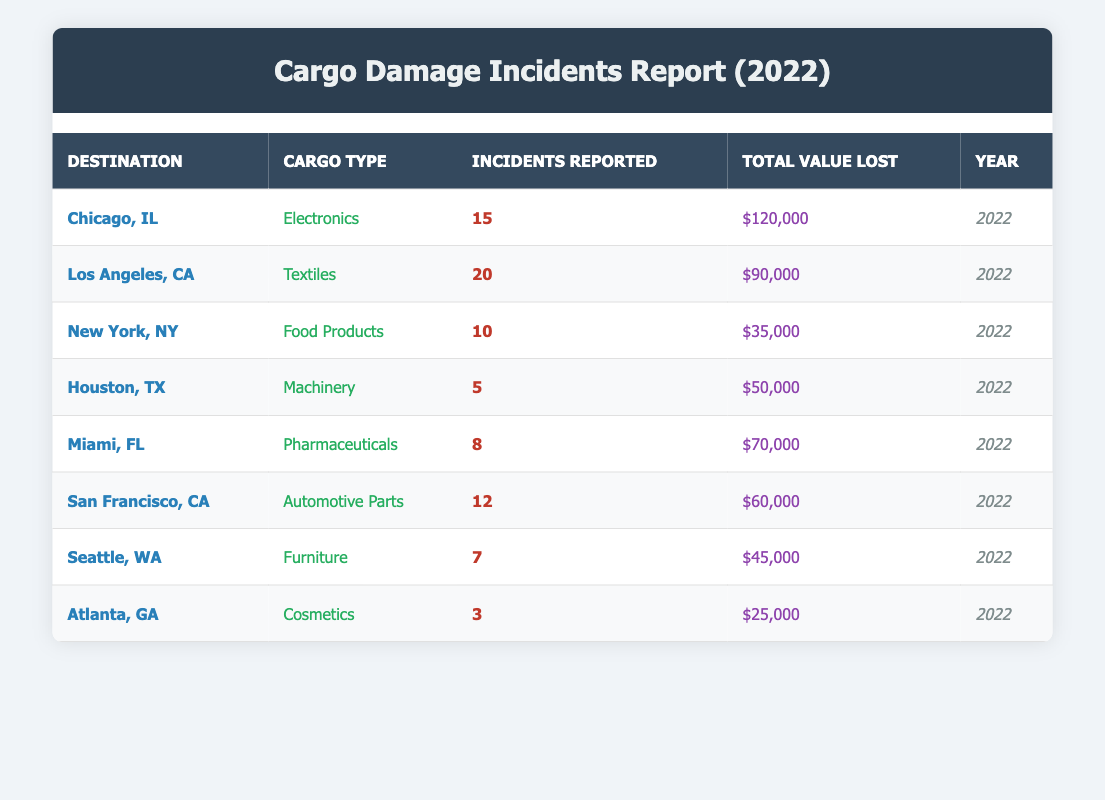What was the total value lost for cargo damages reported in New York, NY? The table shows that the total value lost for cargo damages reported in New York, NY is $35,000.
Answer: $35,000 Which destination had the highest number of incidents reported? According to the table, Los Angeles, CA had the highest number of incidents reported with a total of 20 incidents.
Answer: Los Angeles, CA What is the combined total value lost for all incidents involving Electronics and Pharmaceuticals? In the table, the total value lost for Electronics (Chicago, IL) is $120,000 and for Pharmaceuticals (Miami, FL) is $70,000. Summing these values gives $120,000 + $70,000 = $190,000.
Answer: $190,000 Did any destination report zero incidents for the year 2022? The table lists incidents from various destinations, but all of them reported some incidents. Therefore, there are no destinations with zero incidents reported in 2022.
Answer: No What is the average number of incidents reported for cargo types that had more than 10 incidents? The cargo types with more than 10 incidents are Electronics (15), Textiles (20), and Automotive Parts (12). Adding these gives a total of 15 + 20 + 12 = 47 incidents. Dividing by 3 cargo types gives an average of 47 / 3 ≈ 15.67.
Answer: Approximately 15.67 